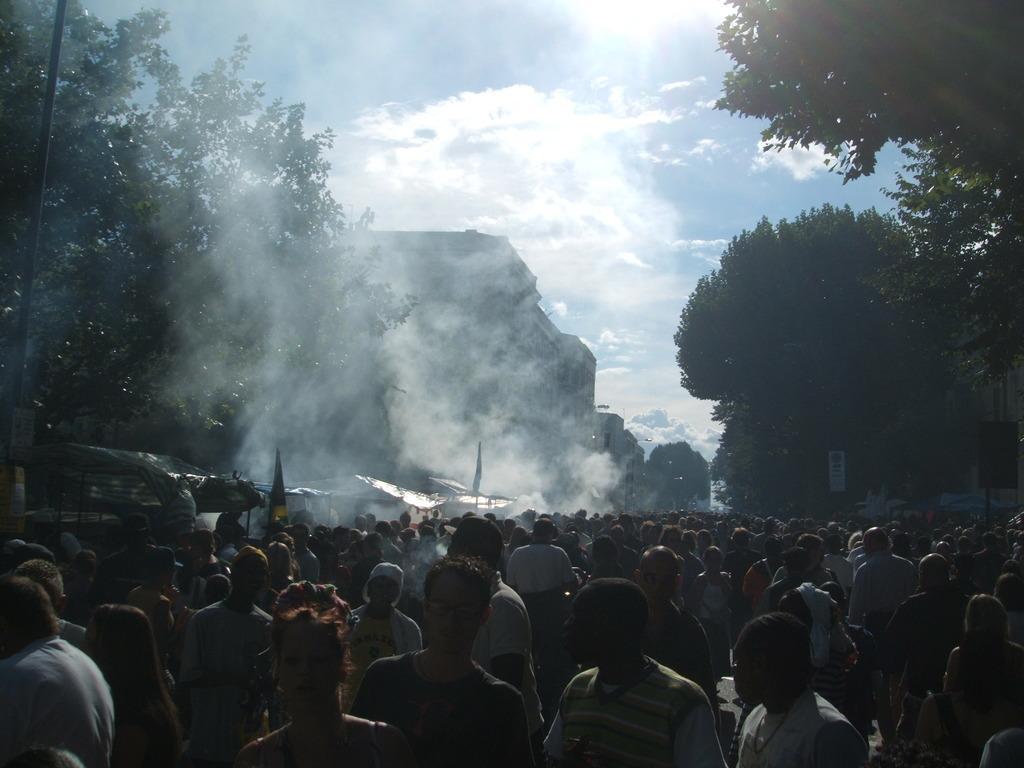Please provide a concise description of this image. In this image, there are a few people, buildings, trees, flags and sheds. We can also see a pole and a board. We can see the sky with clouds. 